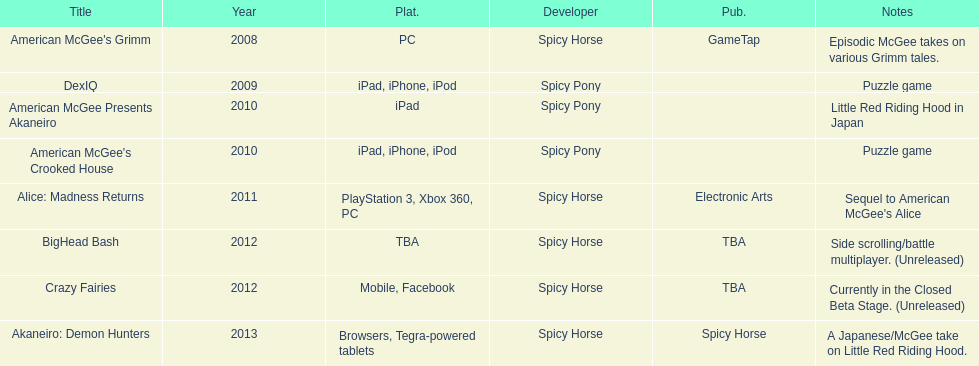What was the only game published by electronic arts? Alice: Madness Returns. 